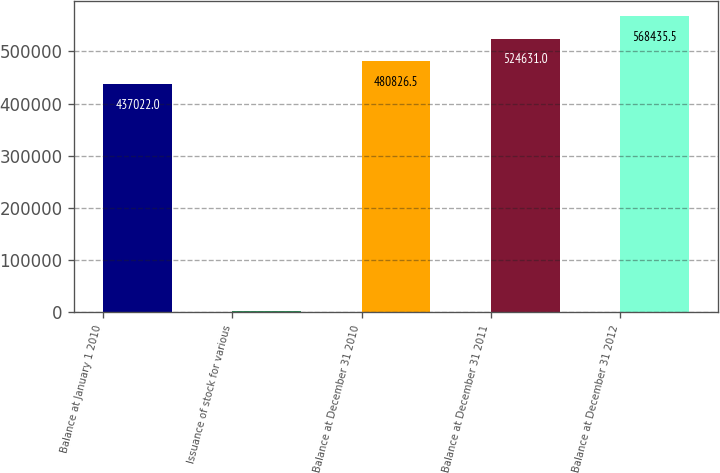Convert chart to OTSL. <chart><loc_0><loc_0><loc_500><loc_500><bar_chart><fcel>Balance at January 1 2010<fcel>Issuance of stock for various<fcel>Balance at December 31 2010<fcel>Balance at December 31 2011<fcel>Balance at December 31 2012<nl><fcel>437022<fcel>1849<fcel>480826<fcel>524631<fcel>568436<nl></chart> 